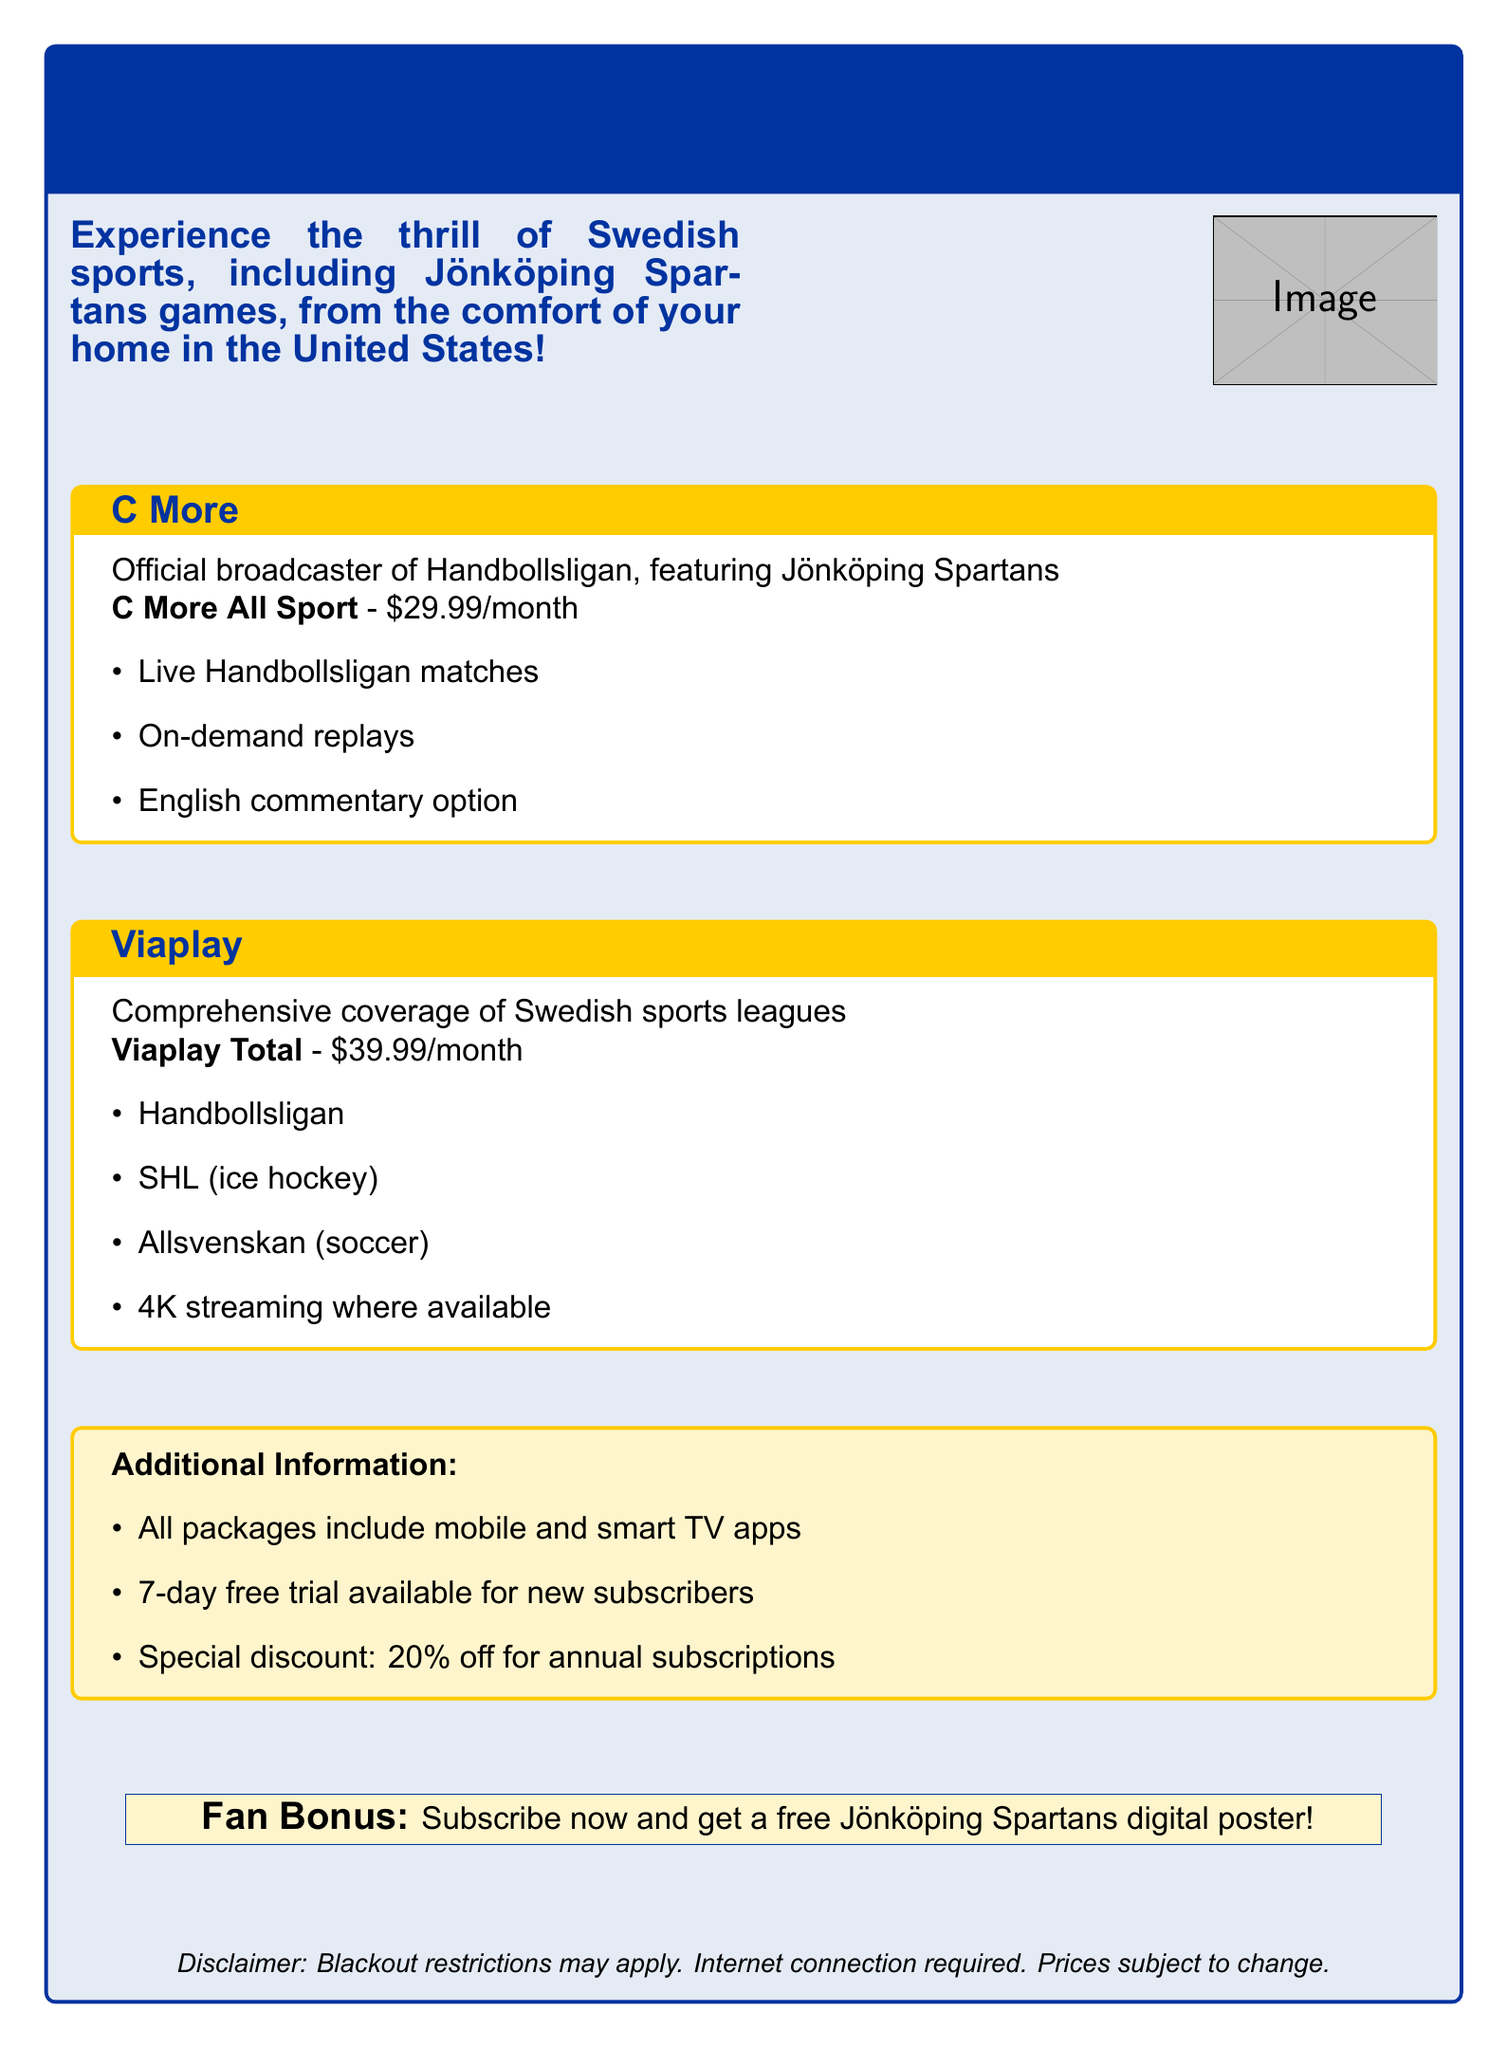What is the name of the official broadcaster of Handbollsligan? The document states that C More is the official broadcaster of Handbollsligan.
Answer: C More How much does the C More All Sport package cost? The cost of the C More All Sport package is explicitly mentioned in the document.
Answer: $29.99/month What is included in the Viaplay Total package? This question asks for the sports covered by the Viaplay Total package, which includes multiple leagues as stated in the document.
Answer: Handbollsligan, SHL, Allsvenskan What is the special discount for annual subscriptions? The document mentions a special discount for subscribers who choose the annual subscription.
Answer: 20% off What type of streaming quality is available with Viaplay Total? The document indicates that Viaplay Total offers a specific quality of streaming.
Answer: 4K streaming Is there a free trial available for new subscribers? The document provides information about the availability of a free trial for new subscribers.
Answer: Yes What is the fan bonus for subscribing now? The document highlights a specific bonus offered to fans who subscribe, which indicates additional engagement.
Answer: Free Jönköping Spartans digital poster What additional features are included in all packages? This question seeks to identify common features outlined in the document for all streaming packages.
Answer: Mobile and smart TV apps 